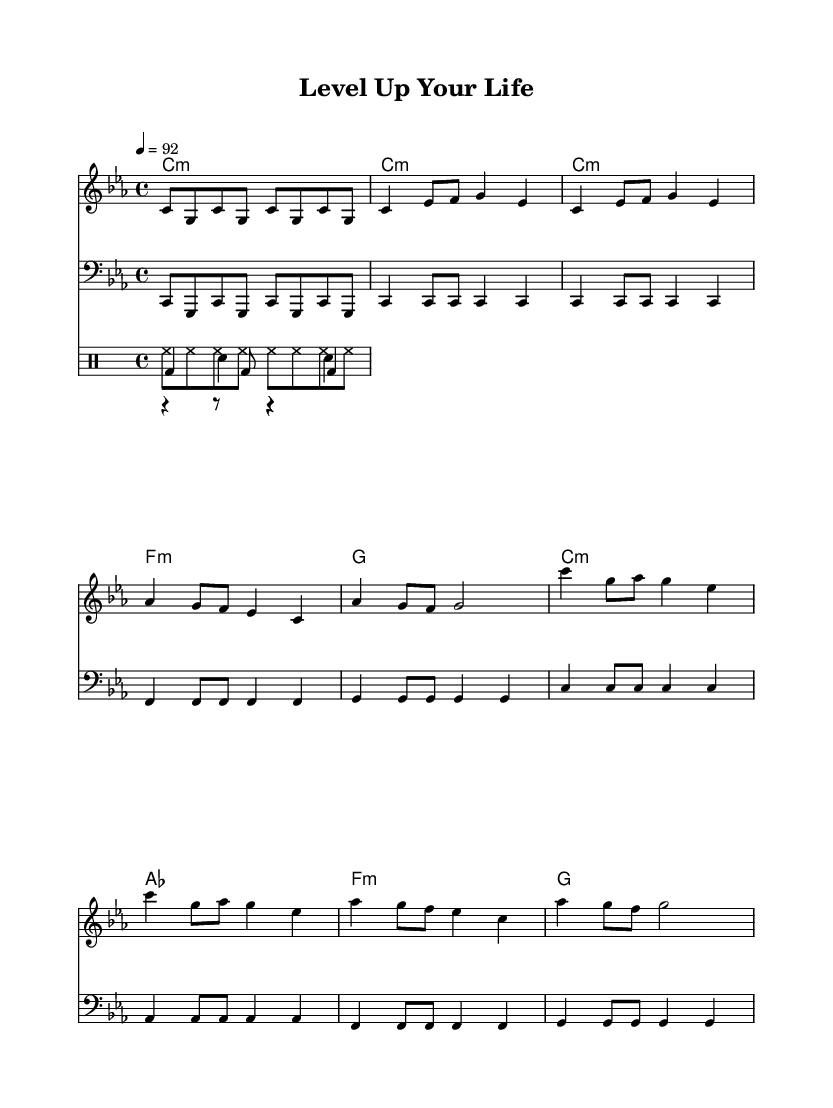What is the key signature of this music? The key signature is C minor, which contains the notes C, D, E-flat, F, G, A-flat, and B-flat. This can be deduced from the presence of E-flat and A-flat in the melody and harmonies.
Answer: C minor What is the time signature of this music? The time signature is 4/4, indicated near the beginning of the sheet music and applies throughout the piece, allowing for a steady and even rhythm.
Answer: 4/4 What is the tempo marking of the piece? The tempo marking indicates a tempo of 92 beats per minute, which is specified in the music and defines the speed at which the piece should be performed.
Answer: 92 How many verses are indicated in this composition? There are two verses as suggested by the repetition of the verse lyrics section in the music, indicating a structured approach similar to many hip hop songs.
Answer: Two What motifs can you identify in the melody concerning overcoming challenges? The melody features ascending notes that symbolize rising progression and growth, mirroring themes of overcoming challenges and leveling up in life, typical of hip hop music.
Answer: Ascending notes What are the main themes presented in the chorus lyrics? The chorus lyrics emphasize persistence and facing fears, encouraging listeners to 'level up' in their lives, which aligns with the overall motivational theme of hip hop focused on personal empowerment.
Answer: Persistence and empowerment What rhythmic elements are used in the drum patterns? The drum patterns feature a kick, snare, and hi-hat, creating a typical hip hop beat characterized by a strong bass kick, backbeat snare, and consistent hi-hat rhythm.
Answer: Kick, snare, hi-hat 